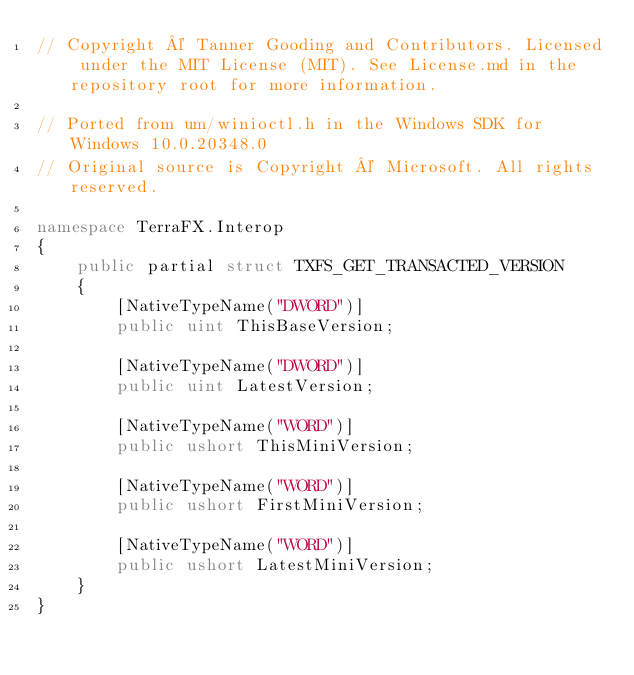Convert code to text. <code><loc_0><loc_0><loc_500><loc_500><_C#_>// Copyright © Tanner Gooding and Contributors. Licensed under the MIT License (MIT). See License.md in the repository root for more information.

// Ported from um/winioctl.h in the Windows SDK for Windows 10.0.20348.0
// Original source is Copyright © Microsoft. All rights reserved.

namespace TerraFX.Interop
{
    public partial struct TXFS_GET_TRANSACTED_VERSION
    {
        [NativeTypeName("DWORD")]
        public uint ThisBaseVersion;

        [NativeTypeName("DWORD")]
        public uint LatestVersion;

        [NativeTypeName("WORD")]
        public ushort ThisMiniVersion;

        [NativeTypeName("WORD")]
        public ushort FirstMiniVersion;

        [NativeTypeName("WORD")]
        public ushort LatestMiniVersion;
    }
}
</code> 